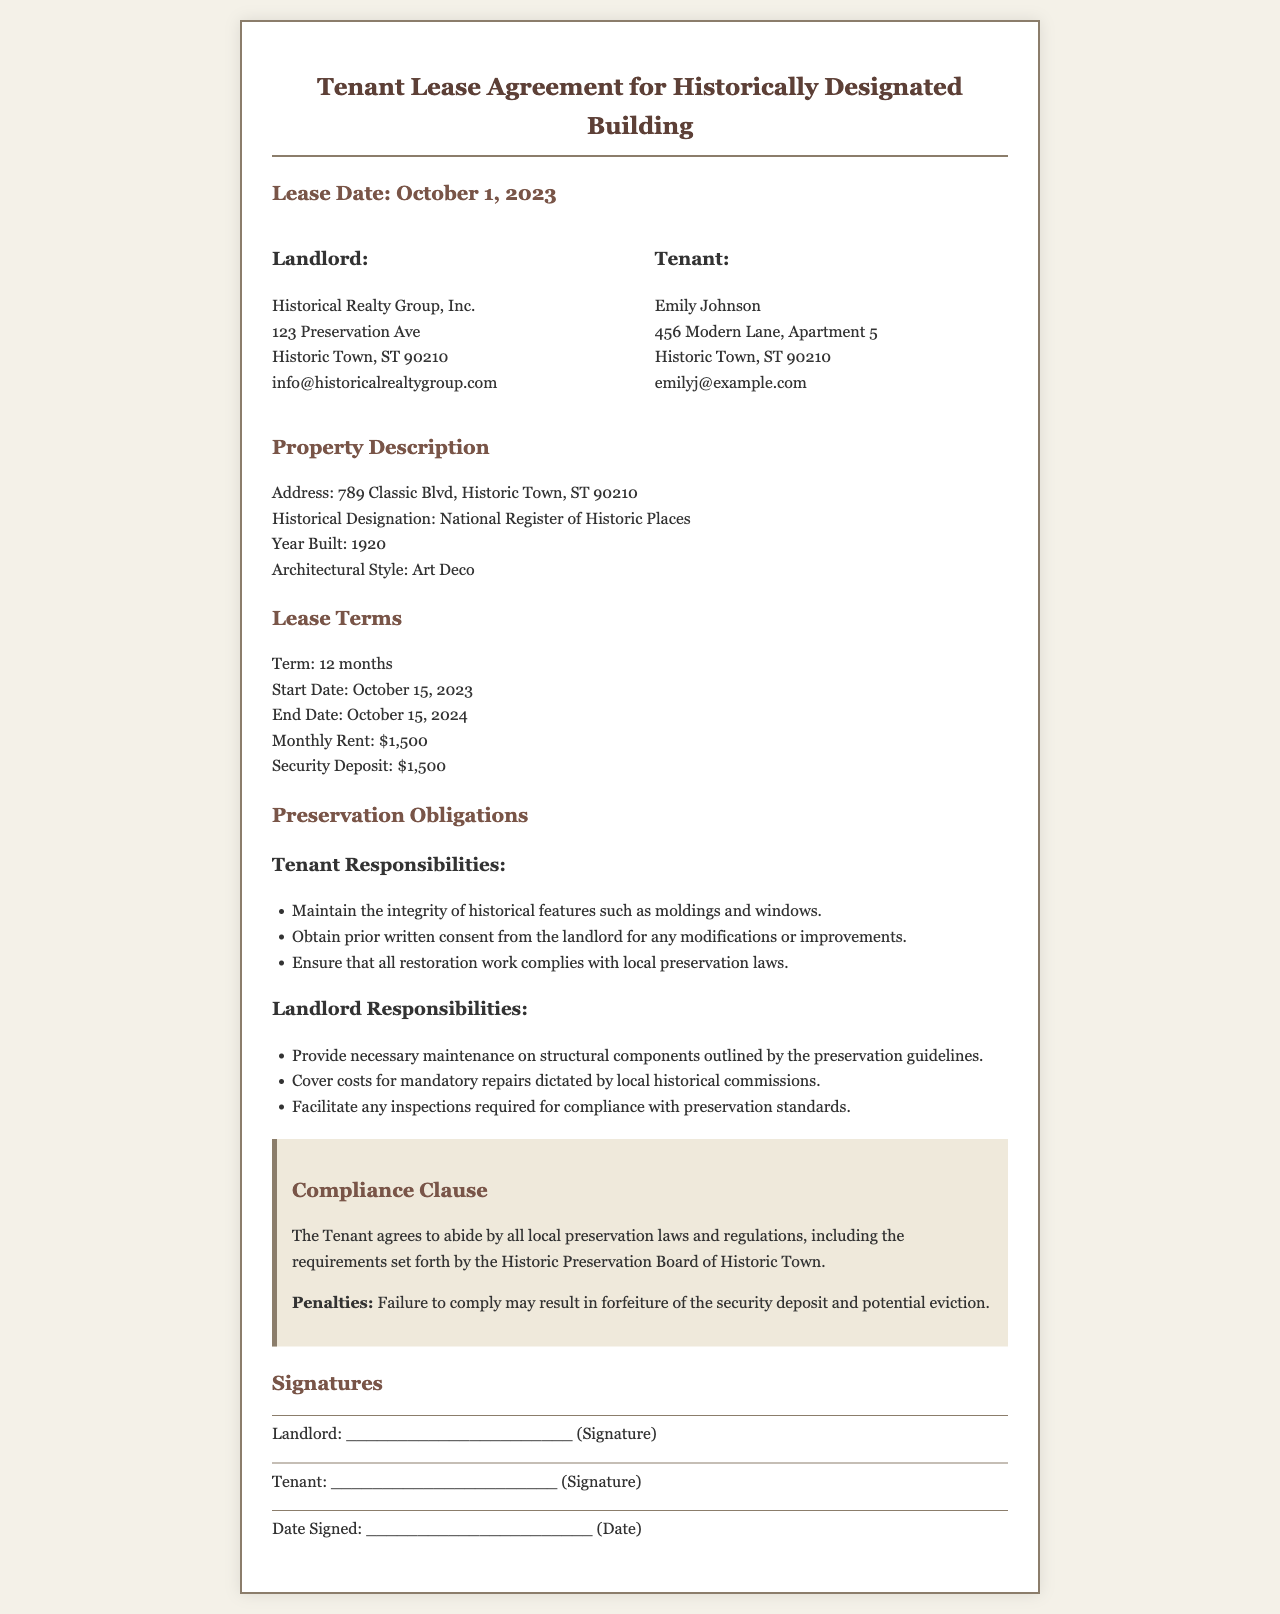what is the name of the landlord? The landlord is named Historical Realty Group, Inc., as stated in the document.
Answer: Historical Realty Group, Inc what is the monthly rent amount? The monthly rent amount is clearly specified in the lease terms section.
Answer: $1,500 what is the lease start date? The lease start date is provided under the lease terms section of the agreement.
Answer: October 15, 2023 what is the security deposit required? The security deposit amount can be found in the lease terms section.
Answer: $1,500 what must the tenant maintain according to their responsibilities? The document lists specific responsibilities for the tenant related to preservation obligations.
Answer: Historical features such as moldings and windows what consequences does the tenant face for failing to comply with preservation laws? The compliance clause outlines repercussions for non-compliance with preservation laws.
Answer: Forfeiture of the security deposit and potential eviction who is responsible for facilitating inspections for compliance? The section detailing landlord responsibilities specifies their role in this aspect.
Answer: Landlord how long is the lease term? The lease term duration is mentioned in the lease terms section.
Answer: 12 months which preservation guidelines must the tenant comply with? The compliance clause indicates adherence to certain local laws regarding preservation.
Answer: Local preservation laws and regulations 